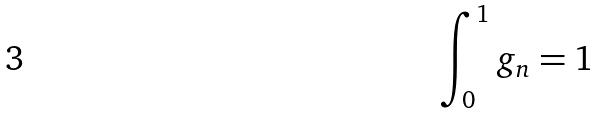<formula> <loc_0><loc_0><loc_500><loc_500>\int _ { 0 } ^ { 1 } g _ { n } = 1</formula> 